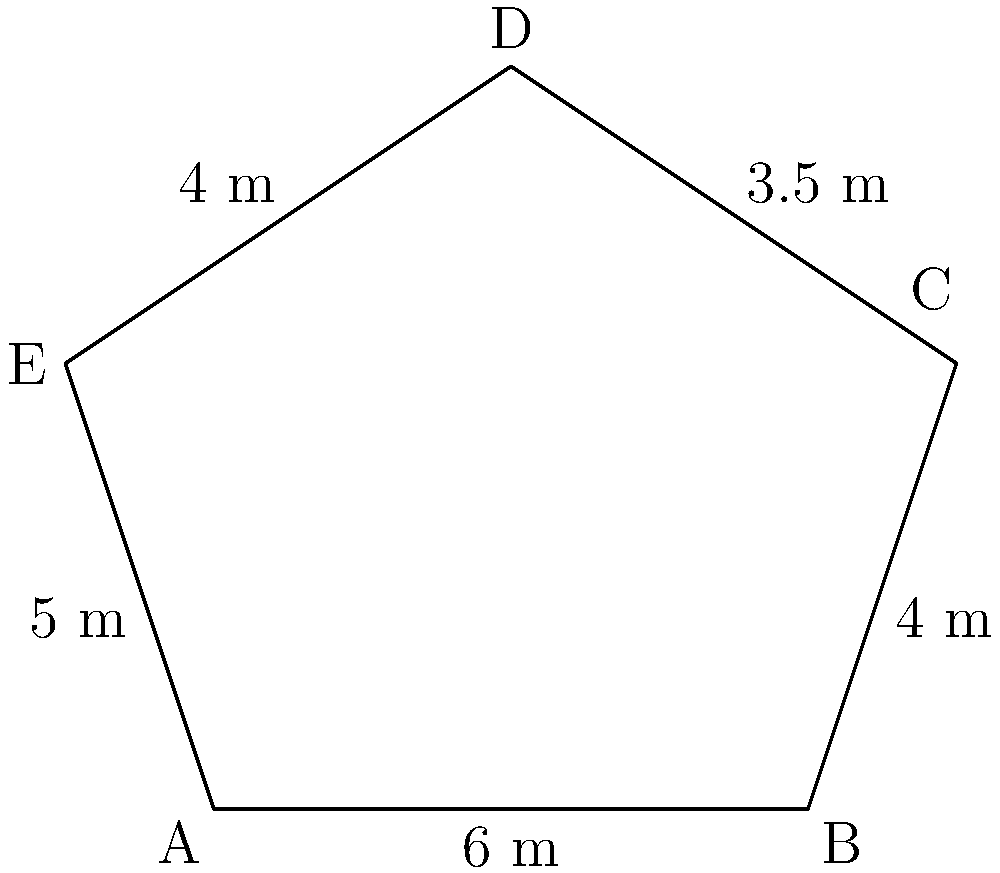In our town, a pentagon-shaped war memorial has been constructed to honor the victims of World War II. The sides of the memorial measure 6 m, 4 m, 3.5 m, 4 m, and 5 m, as shown in the diagram. Calculate the area of this memorial site. To calculate the area of an irregular pentagon, we can use the following steps:

1. Divide the pentagon into three triangles by drawing two diagonals.
2. Calculate the area of each triangle using Heron's formula.
3. Sum up the areas of the three triangles.

Let's start by calculating the semi-perimeter (s) of each triangle:

Triangle ABE:
$s_{ABE} = \frac{6 + 5 + 7.81}{2} = 9.405$ m

Triangle BCE:
$s_{BCE} = \frac{4 + 5 + 6.5}{2} = 7.75$ m

Triangle CDE:
$s_{CDE} = \frac{3.5 + 4 + 6.5}{2} = 7$ m

Now, we can use Heron's formula to calculate the area of each triangle:
$A = \sqrt{s(s-a)(s-b)(s-c)}$

Triangle ABE:
$A_{ABE} = \sqrt{9.405(9.405-6)(9.405-5)(9.405-7.81)} = 15.03$ m²

Triangle BCE:
$A_{BCE} = \sqrt{7.75(7.75-4)(7.75-5)(7.75-6.5)} = 12.37$ m²

Triangle CDE:
$A_{CDE} = \sqrt{7(7-3.5)(7-4)(7-6.5)} = 6.78$ m²

The total area of the pentagon is the sum of these three triangles:

$A_{total} = A_{ABE} + A_{BCE} + A_{CDE}$
$A_{total} = 15.03 + 12.37 + 6.78 = 34.18$ m²
Answer: 34.18 m² 